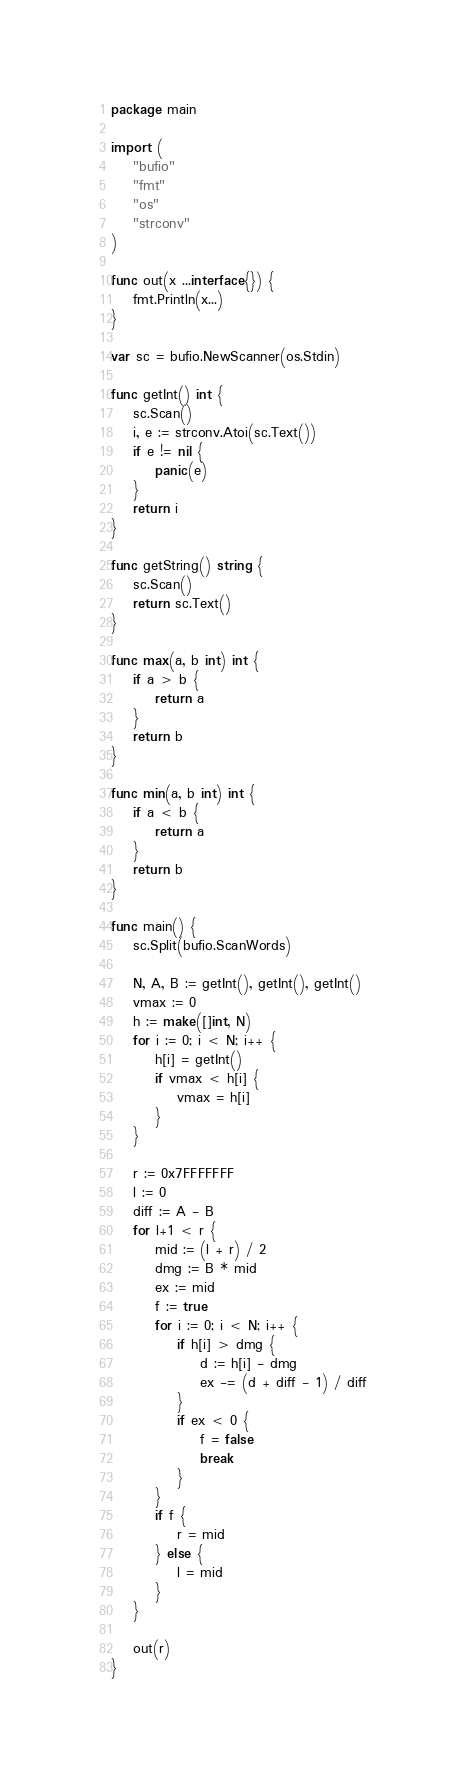Convert code to text. <code><loc_0><loc_0><loc_500><loc_500><_Go_>package main

import (
	"bufio"
	"fmt"
	"os"
	"strconv"
)

func out(x ...interface{}) {
	fmt.Println(x...)
}

var sc = bufio.NewScanner(os.Stdin)

func getInt() int {
	sc.Scan()
	i, e := strconv.Atoi(sc.Text())
	if e != nil {
		panic(e)
	}
	return i
}

func getString() string {
	sc.Scan()
	return sc.Text()
}

func max(a, b int) int {
	if a > b {
		return a
	}
	return b
}

func min(a, b int) int {
	if a < b {
		return a
	}
	return b
}

func main() {
	sc.Split(bufio.ScanWords)

	N, A, B := getInt(), getInt(), getInt()
	vmax := 0
	h := make([]int, N)
	for i := 0; i < N; i++ {
		h[i] = getInt()
		if vmax < h[i] {
			vmax = h[i]
		}
	}

	r := 0x7FFFFFFF
	l := 0
	diff := A - B
	for l+1 < r {
		mid := (l + r) / 2
		dmg := B * mid
		ex := mid
		f := true
		for i := 0; i < N; i++ {
			if h[i] > dmg {
				d := h[i] - dmg
				ex -= (d + diff - 1) / diff
			}
			if ex < 0 {
				f = false
				break
			}
		}
		if f {
			r = mid
		} else {
			l = mid
		}
	}

	out(r)
}
</code> 